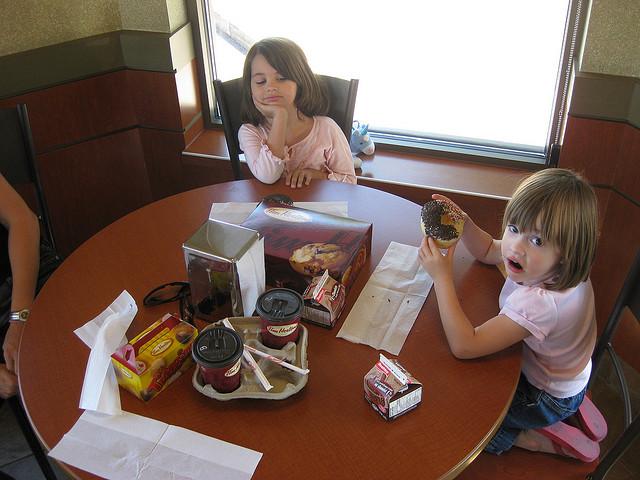Are both children sitting in the chairs?
Answer briefly. Yes. Is the child on the left bored?
Quick response, please. Yes. What is in the small yellow box?
Give a very brief answer. Tea. What is keeping them cool?
Answer briefly. Air conditioning. What is the donut wrapped in?
Concise answer only. Chocolate. 